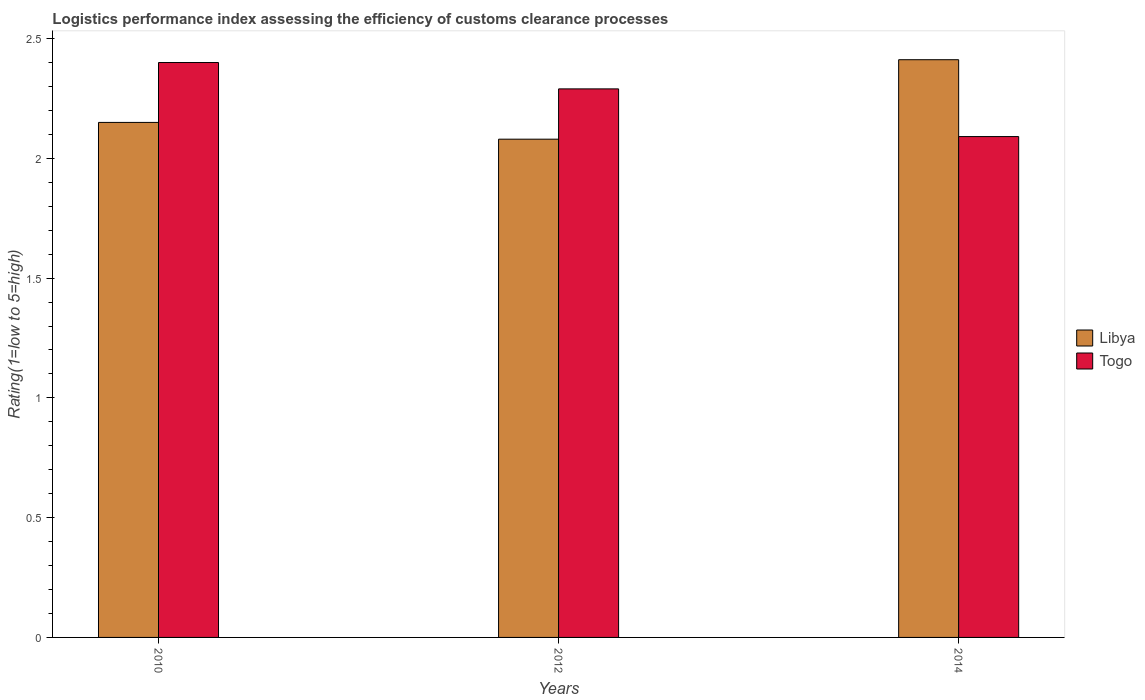Are the number of bars per tick equal to the number of legend labels?
Offer a terse response. Yes. How many bars are there on the 3rd tick from the left?
Your answer should be very brief. 2. What is the Logistic performance index in Libya in 2010?
Make the answer very short. 2.15. Across all years, what is the maximum Logistic performance index in Libya?
Your answer should be compact. 2.41. Across all years, what is the minimum Logistic performance index in Libya?
Ensure brevity in your answer.  2.08. What is the total Logistic performance index in Libya in the graph?
Your answer should be compact. 6.64. What is the difference between the Logistic performance index in Libya in 2010 and that in 2012?
Your answer should be very brief. 0.07. What is the difference between the Logistic performance index in Togo in 2010 and the Logistic performance index in Libya in 2012?
Offer a terse response. 0.32. What is the average Logistic performance index in Libya per year?
Make the answer very short. 2.21. In the year 2014, what is the difference between the Logistic performance index in Togo and Logistic performance index in Libya?
Provide a succinct answer. -0.32. What is the ratio of the Logistic performance index in Togo in 2010 to that in 2012?
Your response must be concise. 1.05. Is the difference between the Logistic performance index in Togo in 2012 and 2014 greater than the difference between the Logistic performance index in Libya in 2012 and 2014?
Keep it short and to the point. Yes. What is the difference between the highest and the second highest Logistic performance index in Libya?
Provide a short and direct response. 0.26. What is the difference between the highest and the lowest Logistic performance index in Libya?
Provide a succinct answer. 0.33. In how many years, is the Logistic performance index in Libya greater than the average Logistic performance index in Libya taken over all years?
Provide a succinct answer. 1. Is the sum of the Logistic performance index in Togo in 2010 and 2014 greater than the maximum Logistic performance index in Libya across all years?
Provide a succinct answer. Yes. What does the 2nd bar from the left in 2014 represents?
Your answer should be compact. Togo. What does the 2nd bar from the right in 2010 represents?
Give a very brief answer. Libya. How many bars are there?
Your answer should be very brief. 6. Are all the bars in the graph horizontal?
Provide a short and direct response. No. How many years are there in the graph?
Your answer should be very brief. 3. What is the difference between two consecutive major ticks on the Y-axis?
Offer a terse response. 0.5. Are the values on the major ticks of Y-axis written in scientific E-notation?
Your answer should be very brief. No. Does the graph contain grids?
Provide a short and direct response. No. Where does the legend appear in the graph?
Offer a terse response. Center right. What is the title of the graph?
Make the answer very short. Logistics performance index assessing the efficiency of customs clearance processes. Does "Lesotho" appear as one of the legend labels in the graph?
Offer a very short reply. No. What is the label or title of the X-axis?
Keep it short and to the point. Years. What is the label or title of the Y-axis?
Offer a very short reply. Rating(1=low to 5=high). What is the Rating(1=low to 5=high) in Libya in 2010?
Give a very brief answer. 2.15. What is the Rating(1=low to 5=high) in Togo in 2010?
Ensure brevity in your answer.  2.4. What is the Rating(1=low to 5=high) in Libya in 2012?
Your answer should be compact. 2.08. What is the Rating(1=low to 5=high) of Togo in 2012?
Give a very brief answer. 2.29. What is the Rating(1=low to 5=high) of Libya in 2014?
Keep it short and to the point. 2.41. What is the Rating(1=low to 5=high) in Togo in 2014?
Your answer should be compact. 2.09. Across all years, what is the maximum Rating(1=low to 5=high) of Libya?
Provide a short and direct response. 2.41. Across all years, what is the maximum Rating(1=low to 5=high) of Togo?
Keep it short and to the point. 2.4. Across all years, what is the minimum Rating(1=low to 5=high) of Libya?
Make the answer very short. 2.08. Across all years, what is the minimum Rating(1=low to 5=high) of Togo?
Offer a very short reply. 2.09. What is the total Rating(1=low to 5=high) in Libya in the graph?
Provide a succinct answer. 6.64. What is the total Rating(1=low to 5=high) in Togo in the graph?
Your answer should be very brief. 6.78. What is the difference between the Rating(1=low to 5=high) in Libya in 2010 and that in 2012?
Your answer should be compact. 0.07. What is the difference between the Rating(1=low to 5=high) in Togo in 2010 and that in 2012?
Keep it short and to the point. 0.11. What is the difference between the Rating(1=low to 5=high) in Libya in 2010 and that in 2014?
Your response must be concise. -0.26. What is the difference between the Rating(1=low to 5=high) in Togo in 2010 and that in 2014?
Provide a succinct answer. 0.31. What is the difference between the Rating(1=low to 5=high) of Libya in 2012 and that in 2014?
Keep it short and to the point. -0.33. What is the difference between the Rating(1=low to 5=high) in Togo in 2012 and that in 2014?
Your answer should be compact. 0.2. What is the difference between the Rating(1=low to 5=high) in Libya in 2010 and the Rating(1=low to 5=high) in Togo in 2012?
Make the answer very short. -0.14. What is the difference between the Rating(1=low to 5=high) of Libya in 2010 and the Rating(1=low to 5=high) of Togo in 2014?
Give a very brief answer. 0.06. What is the difference between the Rating(1=low to 5=high) of Libya in 2012 and the Rating(1=low to 5=high) of Togo in 2014?
Offer a terse response. -0.01. What is the average Rating(1=low to 5=high) in Libya per year?
Your answer should be very brief. 2.21. What is the average Rating(1=low to 5=high) in Togo per year?
Your answer should be compact. 2.26. In the year 2010, what is the difference between the Rating(1=low to 5=high) in Libya and Rating(1=low to 5=high) in Togo?
Provide a succinct answer. -0.25. In the year 2012, what is the difference between the Rating(1=low to 5=high) in Libya and Rating(1=low to 5=high) in Togo?
Offer a terse response. -0.21. In the year 2014, what is the difference between the Rating(1=low to 5=high) of Libya and Rating(1=low to 5=high) of Togo?
Ensure brevity in your answer.  0.32. What is the ratio of the Rating(1=low to 5=high) in Libya in 2010 to that in 2012?
Ensure brevity in your answer.  1.03. What is the ratio of the Rating(1=low to 5=high) in Togo in 2010 to that in 2012?
Make the answer very short. 1.05. What is the ratio of the Rating(1=low to 5=high) in Libya in 2010 to that in 2014?
Your response must be concise. 0.89. What is the ratio of the Rating(1=low to 5=high) in Togo in 2010 to that in 2014?
Provide a succinct answer. 1.15. What is the ratio of the Rating(1=low to 5=high) of Libya in 2012 to that in 2014?
Provide a succinct answer. 0.86. What is the ratio of the Rating(1=low to 5=high) of Togo in 2012 to that in 2014?
Make the answer very short. 1.1. What is the difference between the highest and the second highest Rating(1=low to 5=high) of Libya?
Keep it short and to the point. 0.26. What is the difference between the highest and the second highest Rating(1=low to 5=high) of Togo?
Your response must be concise. 0.11. What is the difference between the highest and the lowest Rating(1=low to 5=high) in Libya?
Offer a very short reply. 0.33. What is the difference between the highest and the lowest Rating(1=low to 5=high) of Togo?
Offer a terse response. 0.31. 